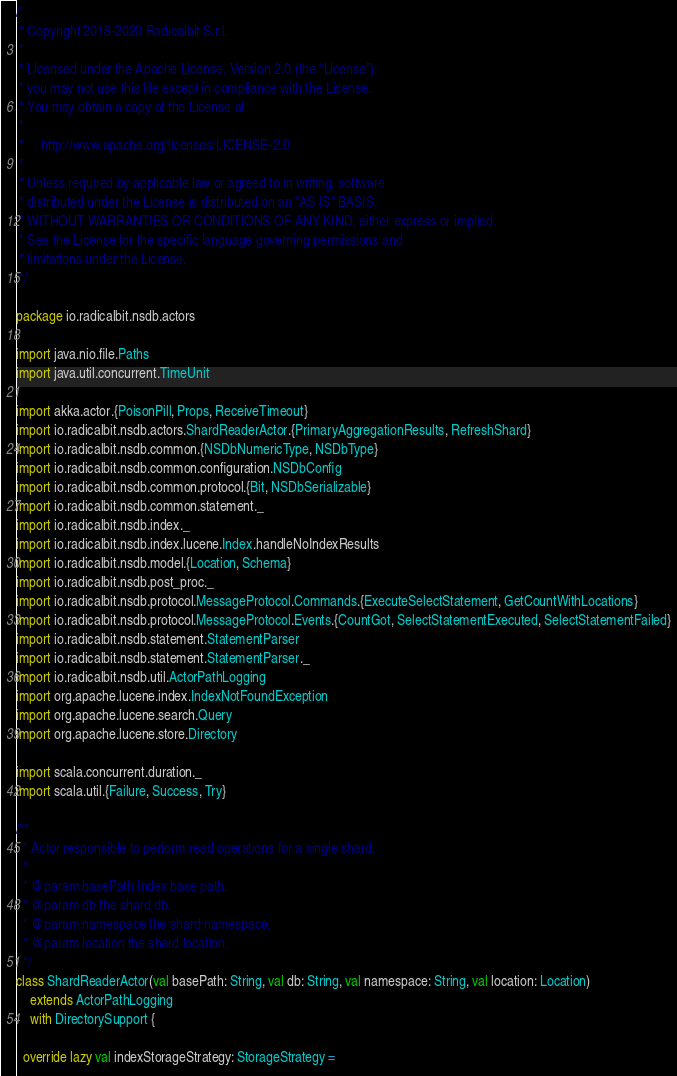<code> <loc_0><loc_0><loc_500><loc_500><_Scala_>/*
 * Copyright 2018-2020 Radicalbit S.r.l.
 *
 * Licensed under the Apache License, Version 2.0 (the "License");
 * you may not use this file except in compliance with the License.
 * You may obtain a copy of the License at
 *
 *     http://www.apache.org/licenses/LICENSE-2.0
 *
 * Unless required by applicable law or agreed to in writing, software
 * distributed under the License is distributed on an "AS IS" BASIS,
 * WITHOUT WARRANTIES OR CONDITIONS OF ANY KIND, either express or implied.
 * See the License for the specific language governing permissions and
 * limitations under the License.
 */

package io.radicalbit.nsdb.actors

import java.nio.file.Paths
import java.util.concurrent.TimeUnit

import akka.actor.{PoisonPill, Props, ReceiveTimeout}
import io.radicalbit.nsdb.actors.ShardReaderActor.{PrimaryAggregationResults, RefreshShard}
import io.radicalbit.nsdb.common.{NSDbNumericType, NSDbType}
import io.radicalbit.nsdb.common.configuration.NSDbConfig
import io.radicalbit.nsdb.common.protocol.{Bit, NSDbSerializable}
import io.radicalbit.nsdb.common.statement._
import io.radicalbit.nsdb.index._
import io.radicalbit.nsdb.index.lucene.Index.handleNoIndexResults
import io.radicalbit.nsdb.model.{Location, Schema}
import io.radicalbit.nsdb.post_proc._
import io.radicalbit.nsdb.protocol.MessageProtocol.Commands.{ExecuteSelectStatement, GetCountWithLocations}
import io.radicalbit.nsdb.protocol.MessageProtocol.Events.{CountGot, SelectStatementExecuted, SelectStatementFailed}
import io.radicalbit.nsdb.statement.StatementParser
import io.radicalbit.nsdb.statement.StatementParser._
import io.radicalbit.nsdb.util.ActorPathLogging
import org.apache.lucene.index.IndexNotFoundException
import org.apache.lucene.search.Query
import org.apache.lucene.store.Directory

import scala.concurrent.duration._
import scala.util.{Failure, Success, Try}

/**
  * Actor responsible to perform read operations for a single shard.
  *
  * @param basePath Index base path.
  * @param db the shard db.
  * @param namespace the shard namespace.
  * @param location the shard location.
  */
class ShardReaderActor(val basePath: String, val db: String, val namespace: String, val location: Location)
    extends ActorPathLogging
    with DirectorySupport {

  override lazy val indexStorageStrategy: StorageStrategy =</code> 